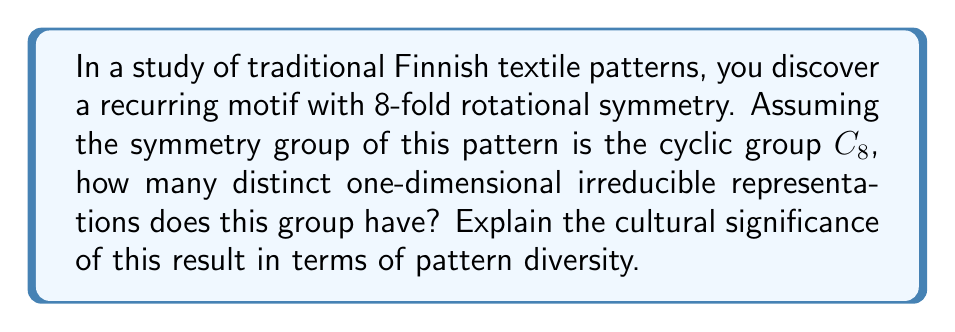Solve this math problem. To solve this problem, we'll follow these steps:

1) First, recall that for a cyclic group $C_n$, the number of distinct one-dimensional irreducible representations is equal to the order of the group, which is $n$.

2) In this case, we have $C_8$, so $n = 8$.

3) Therefore, the number of distinct one-dimensional irreducible representations is 8.

4) To understand the cultural significance, we need to interpret what these representations mean in the context of patterns:

   a) Each irreducible representation corresponds to a way the pattern can transform under rotation while maintaining its overall structure.
   
   b) The 8 representations correspond to rotations by multiples of 45° (360°/8 = 45°).
   
   c) This means the pattern has 8 distinct "orientations" that are preserved under rotation.

5) Cultural significance:
   
   a) The high number of irreducible representations (8) suggests a complex and rich pattern with many symmetries.
   
   b) This complexity could reflect the sophisticated textile traditions in Finnish culture.
   
   c) The 8-fold symmetry might represent important cultural concepts, such as the eight seasons recognized in Sámi culture (a Finnish indigenous group).
   
   d) The diversity of representations allows for various interpretations and uses of the pattern in different cultural contexts, enhancing its versatility and significance in Finnish textile art.
Answer: 8 irreducible representations, reflecting pattern complexity and cultural richness. 